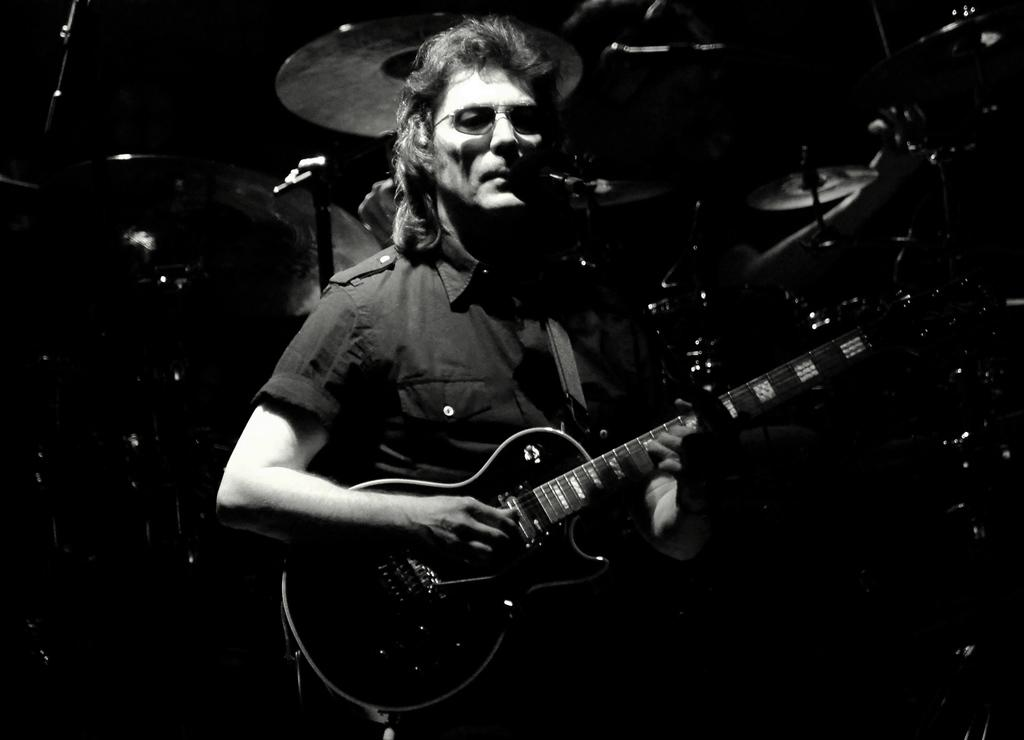What is the man in the image doing? The man is playing a guitar. What instrument can be seen in the background of the image? There is a drum kit in the background of the image. How many rabbits are sitting on the lamp in the image? There are no rabbits or lamps present in the image. 